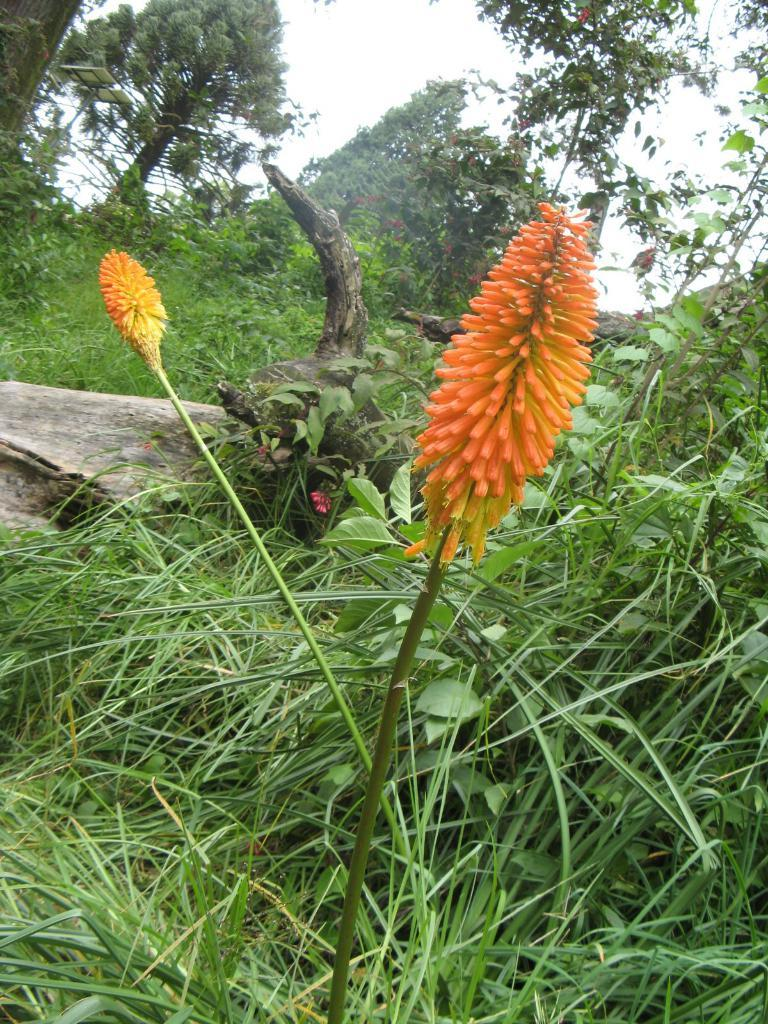What type of plants can be seen in the image? There are flowers, grass, and trees in the image. Can you describe the natural environment depicted in the image? The image features a combination of flowers, grass, and trees, which suggests a natural setting. What type of drug is being sold by the visitor in the image? There is no visitor or drug present in the image; it features flowers, grass, and trees. 